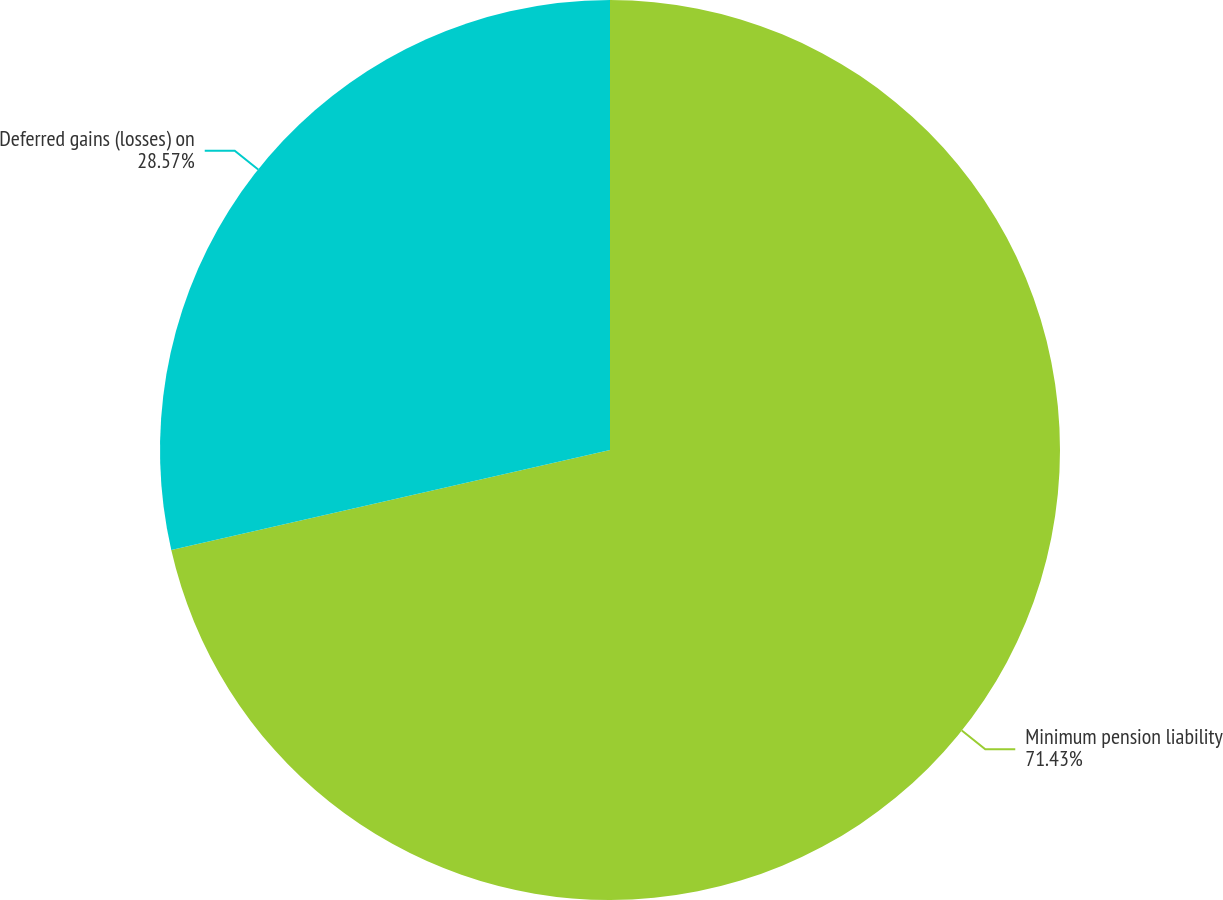Convert chart. <chart><loc_0><loc_0><loc_500><loc_500><pie_chart><fcel>Minimum pension liability<fcel>Deferred gains (losses) on<nl><fcel>71.43%<fcel>28.57%<nl></chart> 